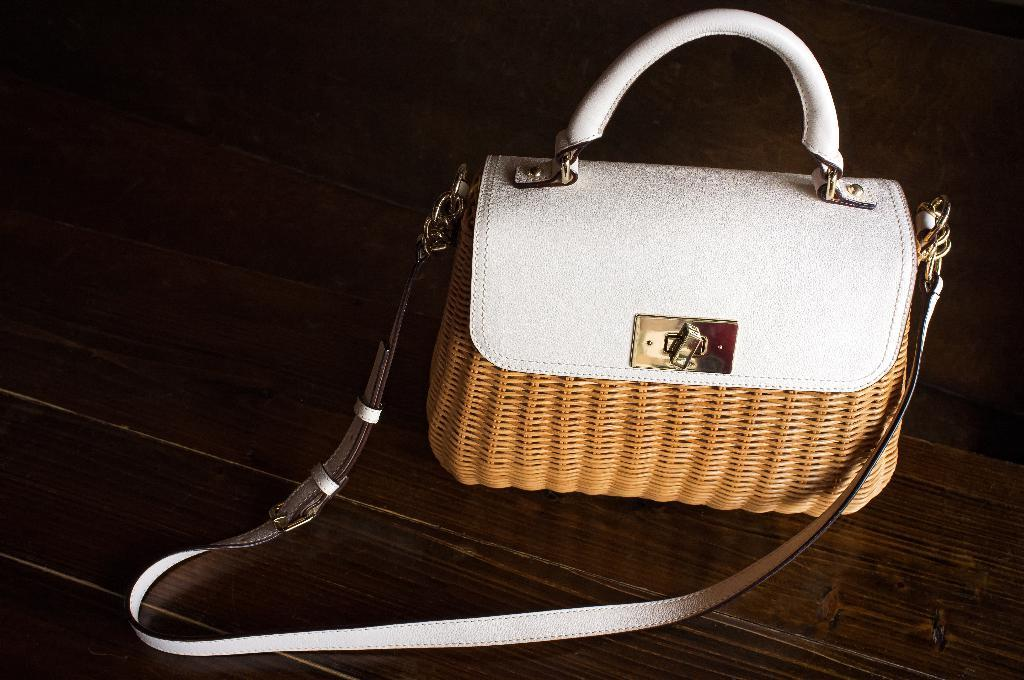What type of handbag is visible in the image? There is a leather handbag in the image. Where is the handbag located? The handbag is on a table. What type of event is taking place in the image involving a squirrel? There is no squirrel or event present in the image; it only features a leather handbag on a table. 